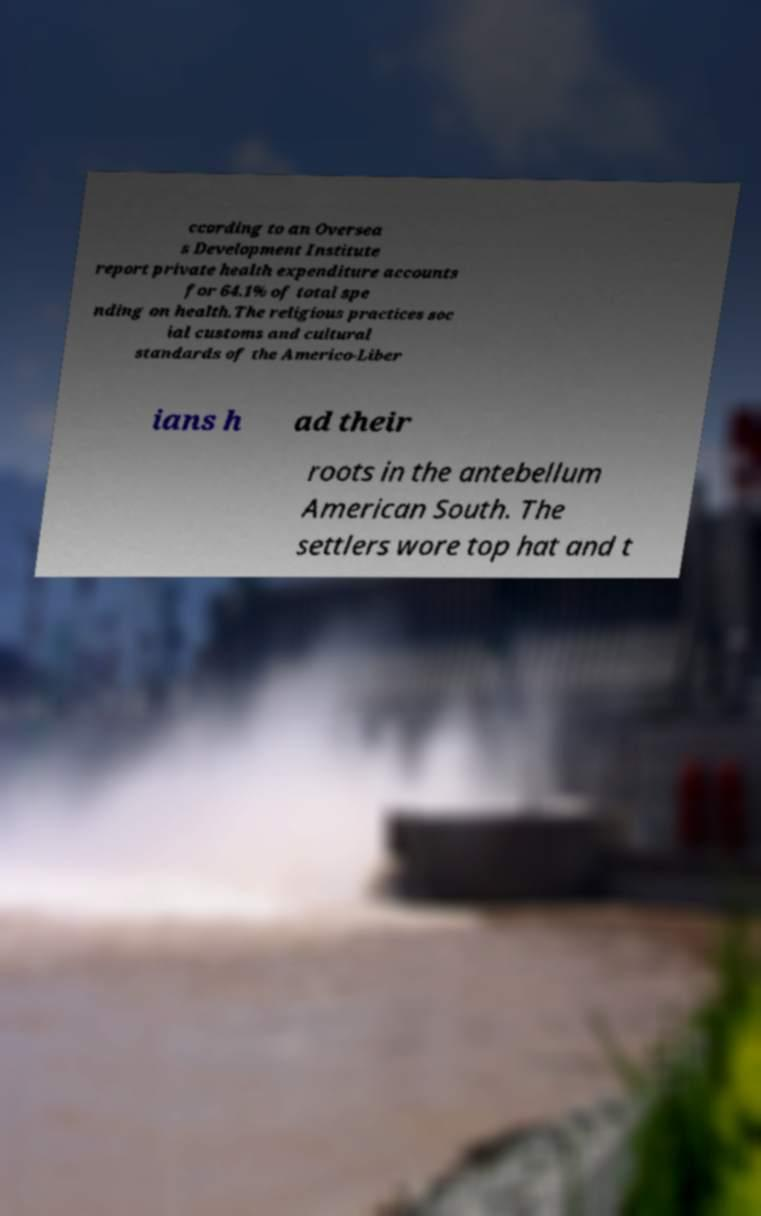Could you extract and type out the text from this image? ccording to an Oversea s Development Institute report private health expenditure accounts for 64.1% of total spe nding on health.The religious practices soc ial customs and cultural standards of the Americo-Liber ians h ad their roots in the antebellum American South. The settlers wore top hat and t 